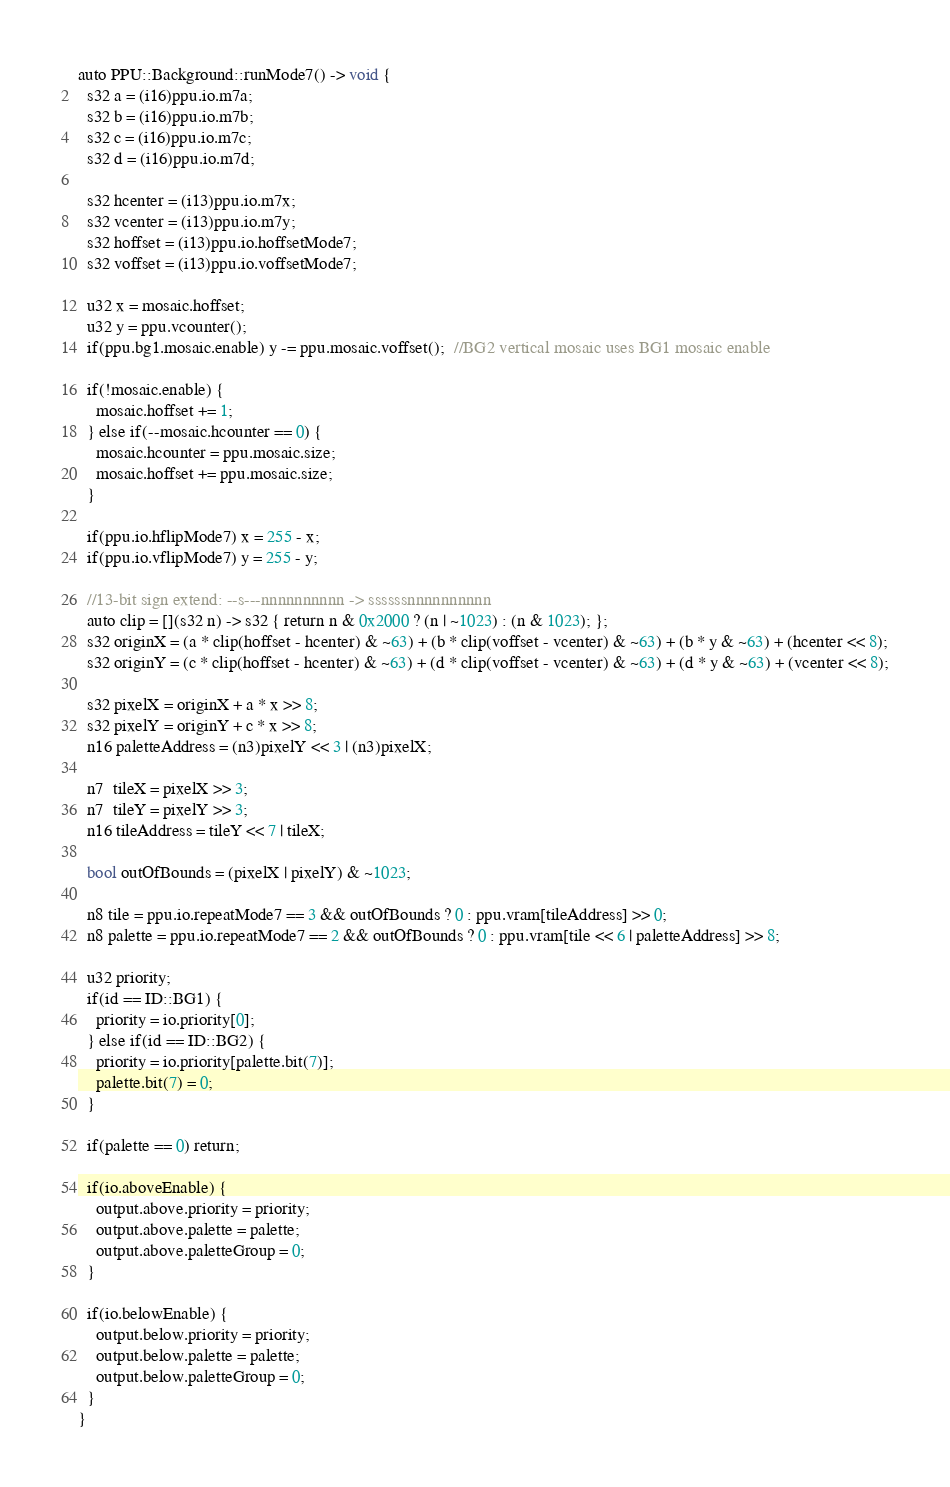<code> <loc_0><loc_0><loc_500><loc_500><_C++_>auto PPU::Background::runMode7() -> void {
  s32 a = (i16)ppu.io.m7a;
  s32 b = (i16)ppu.io.m7b;
  s32 c = (i16)ppu.io.m7c;
  s32 d = (i16)ppu.io.m7d;

  s32 hcenter = (i13)ppu.io.m7x;
  s32 vcenter = (i13)ppu.io.m7y;
  s32 hoffset = (i13)ppu.io.hoffsetMode7;
  s32 voffset = (i13)ppu.io.voffsetMode7;

  u32 x = mosaic.hoffset;
  u32 y = ppu.vcounter();
  if(ppu.bg1.mosaic.enable) y -= ppu.mosaic.voffset();  //BG2 vertical mosaic uses BG1 mosaic enable

  if(!mosaic.enable) {
    mosaic.hoffset += 1;
  } else if(--mosaic.hcounter == 0) {
    mosaic.hcounter = ppu.mosaic.size;
    mosaic.hoffset += ppu.mosaic.size;
  }

  if(ppu.io.hflipMode7) x = 255 - x;
  if(ppu.io.vflipMode7) y = 255 - y;

  //13-bit sign extend: --s---nnnnnnnnnn -> ssssssnnnnnnnnnn
  auto clip = [](s32 n) -> s32 { return n & 0x2000 ? (n | ~1023) : (n & 1023); };
  s32 originX = (a * clip(hoffset - hcenter) & ~63) + (b * clip(voffset - vcenter) & ~63) + (b * y & ~63) + (hcenter << 8);
  s32 originY = (c * clip(hoffset - hcenter) & ~63) + (d * clip(voffset - vcenter) & ~63) + (d * y & ~63) + (vcenter << 8);

  s32 pixelX = originX + a * x >> 8;
  s32 pixelY = originY + c * x >> 8;
  n16 paletteAddress = (n3)pixelY << 3 | (n3)pixelX;

  n7  tileX = pixelX >> 3;
  n7  tileY = pixelY >> 3;
  n16 tileAddress = tileY << 7 | tileX;

  bool outOfBounds = (pixelX | pixelY) & ~1023;

  n8 tile = ppu.io.repeatMode7 == 3 && outOfBounds ? 0 : ppu.vram[tileAddress] >> 0;
  n8 palette = ppu.io.repeatMode7 == 2 && outOfBounds ? 0 : ppu.vram[tile << 6 | paletteAddress] >> 8;

  u32 priority;
  if(id == ID::BG1) {
    priority = io.priority[0];
  } else if(id == ID::BG2) {
    priority = io.priority[palette.bit(7)];
    palette.bit(7) = 0;
  }

  if(palette == 0) return;

  if(io.aboveEnable) {
    output.above.priority = priority;
    output.above.palette = palette;
    output.above.paletteGroup = 0;
  }

  if(io.belowEnable) {
    output.below.priority = priority;
    output.below.palette = palette;
    output.below.paletteGroup = 0;
  }
}
</code> 